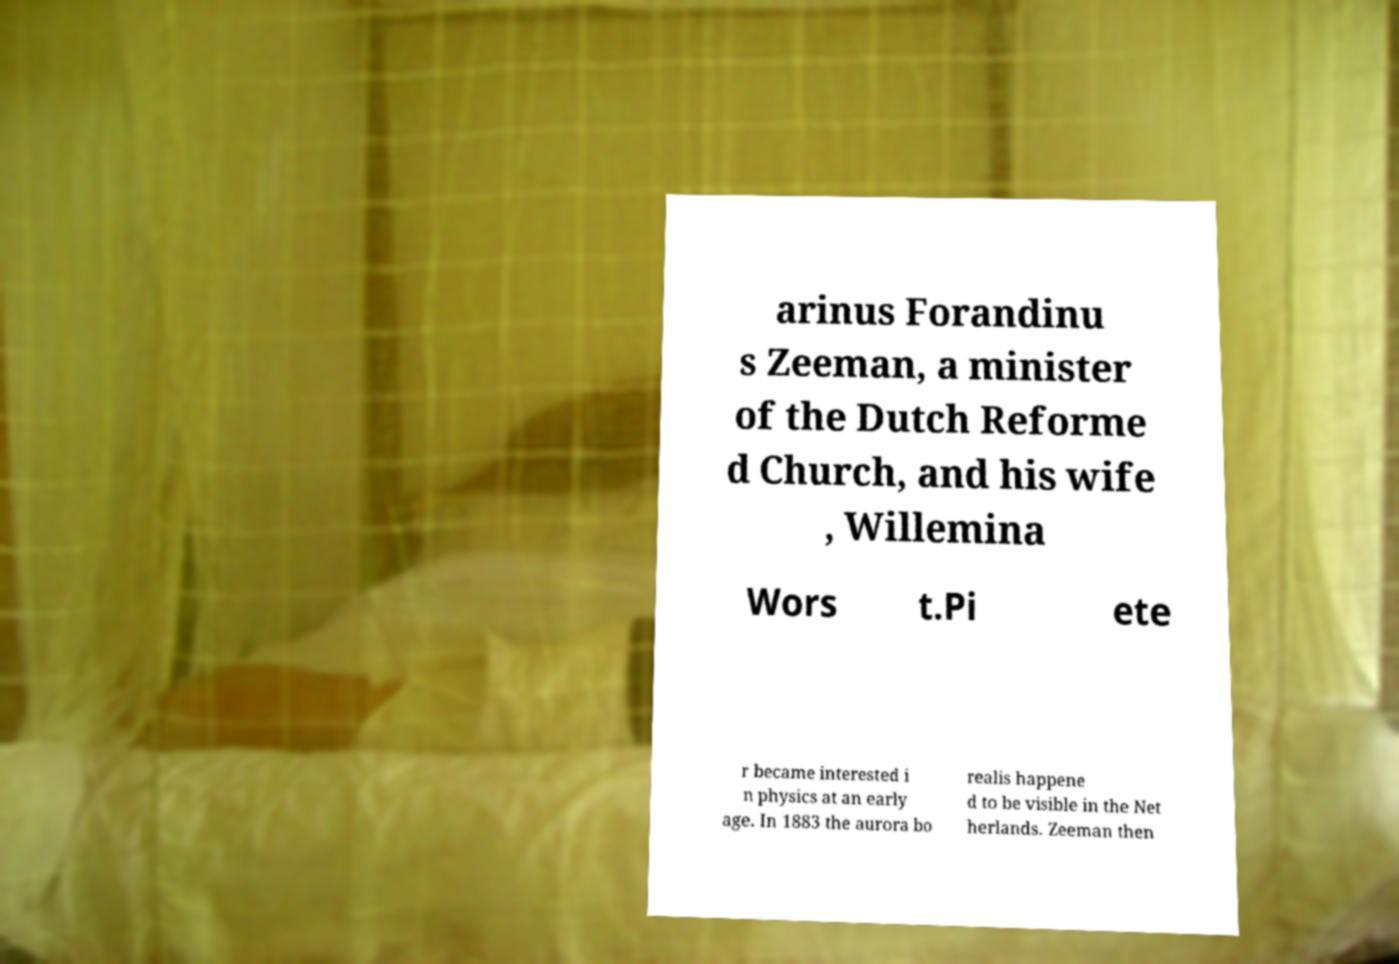I need the written content from this picture converted into text. Can you do that? arinus Forandinu s Zeeman, a minister of the Dutch Reforme d Church, and his wife , Willemina Wors t.Pi ete r became interested i n physics at an early age. In 1883 the aurora bo realis happene d to be visible in the Net herlands. Zeeman then 